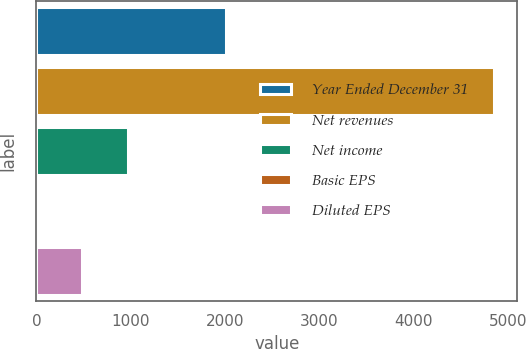<chart> <loc_0><loc_0><loc_500><loc_500><bar_chart><fcel>Year Ended December 31<fcel>Net revenues<fcel>Net income<fcel>Basic EPS<fcel>Diluted EPS<nl><fcel>2011<fcel>4857<fcel>971.97<fcel>0.71<fcel>486.34<nl></chart> 